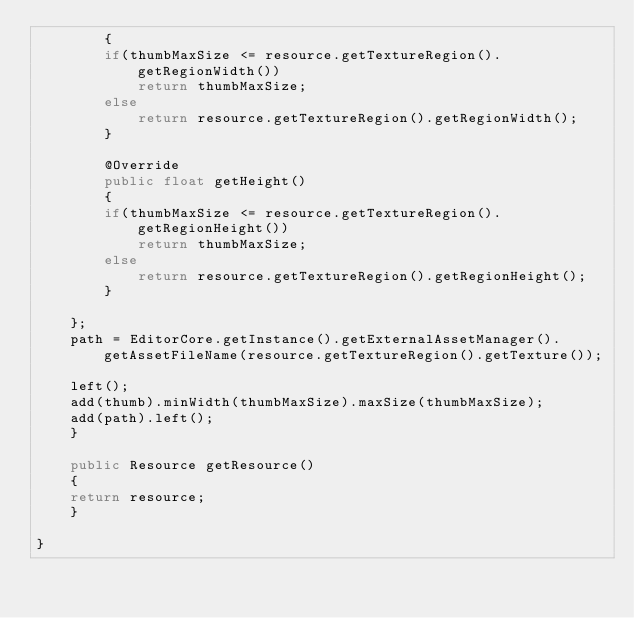Convert code to text. <code><loc_0><loc_0><loc_500><loc_500><_Java_>	    {
		if(thumbMaxSize <= resource.getTextureRegion().getRegionWidth())
		    return thumbMaxSize;
		else
		    return resource.getTextureRegion().getRegionWidth();
	    }
	    
	    @Override
	    public float getHeight()
	    {
		if(thumbMaxSize <= resource.getTextureRegion().getRegionHeight())
		    return thumbMaxSize;
		else
		    return resource.getTextureRegion().getRegionHeight();
	    }
	    
	};
	path = EditorCore.getInstance().getExternalAssetManager().getAssetFileName(resource.getTextureRegion().getTexture());
	
	left();
	add(thumb).minWidth(thumbMaxSize).maxSize(thumbMaxSize);
	add(path).left();
    }
    
    public Resource getResource()
    {
	return resource;
    }

}
</code> 